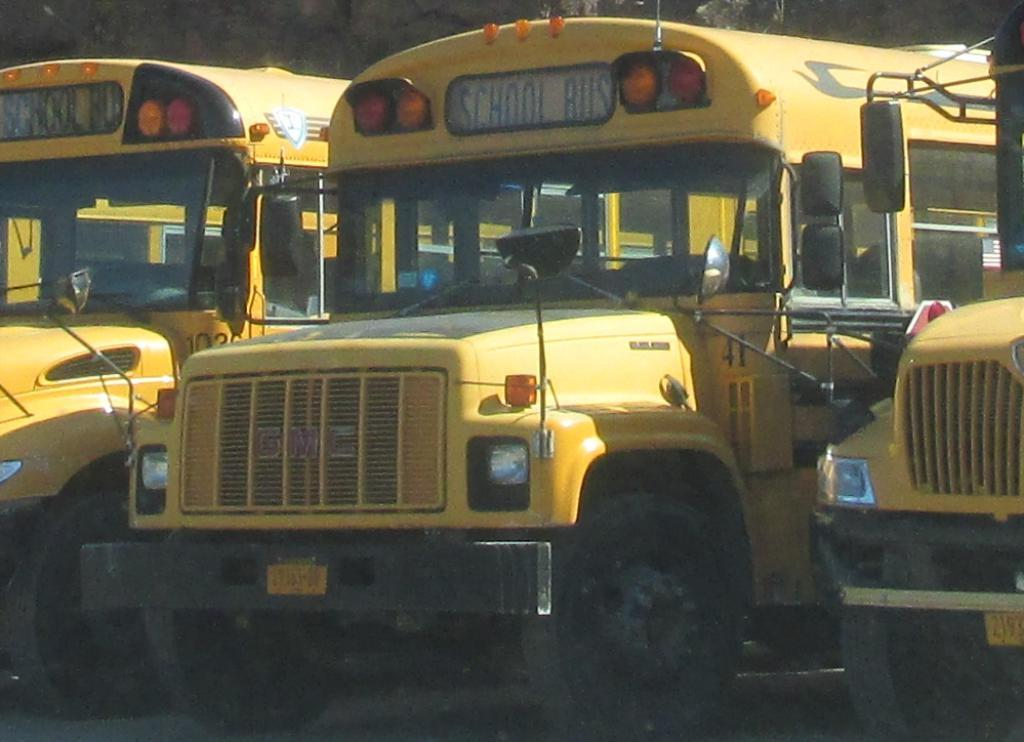What color are the buses in the image? The buses in the image are yellow. What information can be found on the buses? The buses have name boards. What feature can be seen on the buses at night? There are lights on the buses. How many tickets can be seen in the image? There is no mention of tickets in the image, so it is not possible to determine how many there are. 